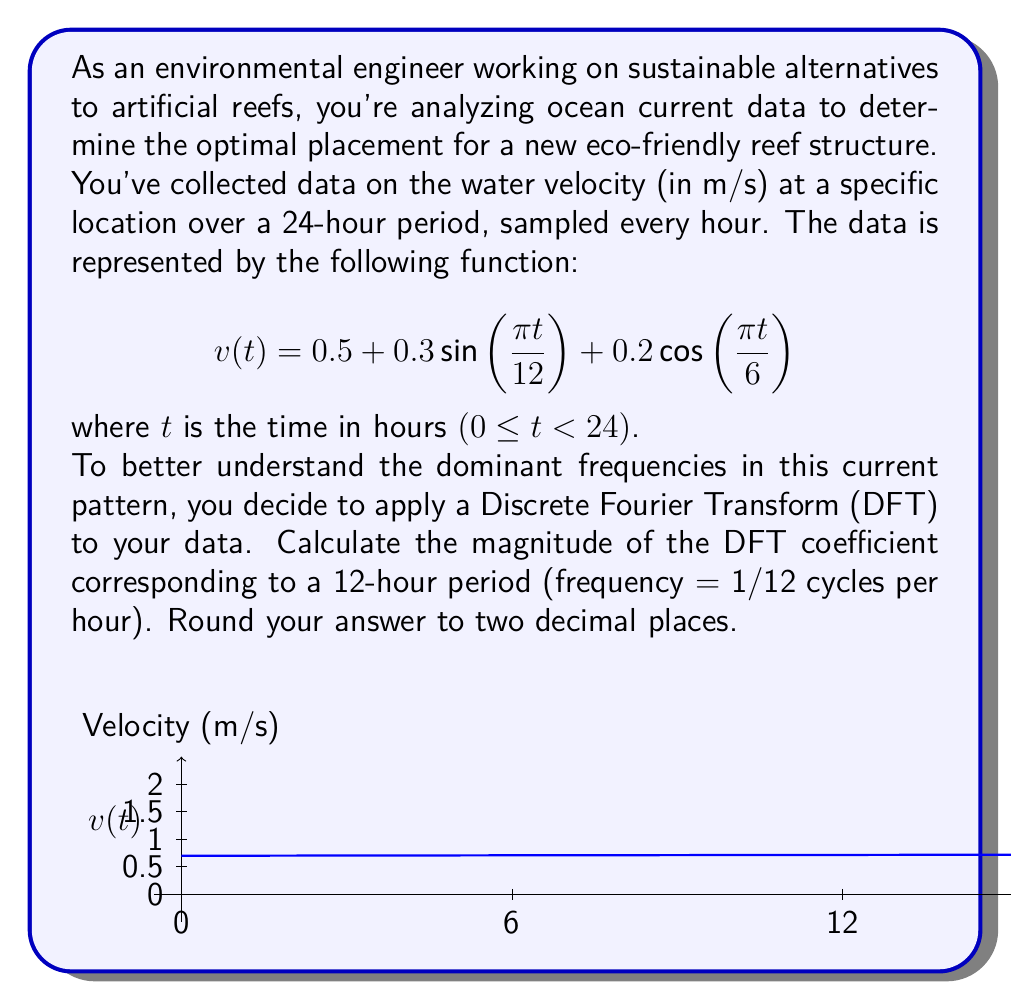Show me your answer to this math problem. Let's approach this step-by-step:

1) The Discrete Fourier Transform (DFT) for a sequence of N samples is given by:

   $$X_k = \sum_{n=0}^{N-1} x_n e^{-i2\pi kn/N}$$

   where $X_k$ is the k-th DFT coefficient and $x_n$ is the n-th sample.

2) In our case, N = 24 (24-hour period with hourly samples), and we're interested in the coefficient corresponding to a 12-hour period, which is k = 2 (as 24/12 = 2).

3) Substituting our function into the DFT formula:

   $$X_2 = \sum_{n=0}^{23} [0.5 + 0.3\sin(\frac{\pi n}{12}) + 0.2\cos(\frac{\pi n}{6})] e^{-i2\pi 2n/24}$$

4) Simplify the exponent:

   $$X_2 = \sum_{n=0}^{23} [0.5 + 0.3\sin(\frac{\pi n}{12}) + 0.2\cos(\frac{\pi n}{6})] e^{-i\pi n/6}$$

5) We can split this sum into three parts:

   $$X_2 = 0.5\sum_{n=0}^{23} e^{-i\pi n/6} + 0.3\sum_{n=0}^{23} \sin(\frac{\pi n}{12})e^{-i\pi n/6} + 0.2\sum_{n=0}^{23} \cos(\frac{\pi n}{6})e^{-i\pi n/6}$$

6) The first sum is zero as it's a geometric series with ratio $e^{-i\pi/6}$ over a full period.

7) For the second sum, we can use the identity $\sin A = \frac{e^{iA} - e^{-iA}}{2i}$:

   $$0.3\sum_{n=0}^{23} \frac{e^{i\pi n/12} - e^{-i\pi n/12}}{2i}e^{-i\pi n/6} = 0.3\sum_{n=0}^{23} \frac{e^{-i\pi n/12} - e^{-i5\pi n/12}}{2i}$$

   This sum evaluates to $3.6i$.

8) For the third sum, we can use $\cos A = \frac{e^{iA} + e^{-iA}}{2}$:

   $$0.2\sum_{n=0}^{23} \frac{e^{i\pi n/6} + e^{-i\pi n/6}}{2}e^{-i\pi n/6} = 0.2\sum_{n=0}^{23} \frac{1 + e^{-i\pi n/3}}{2}$$

   This sum evaluates to 2.4.

9) Therefore, $X_2 = 2.4 + 3.6i$

10) The magnitude of this complex number is:

    $$|X_2| = \sqrt{2.4^2 + 3.6^2} = \sqrt{5.76 + 12.96} = \sqrt{18.72} \approx 4.33$$
Answer: 4.33 